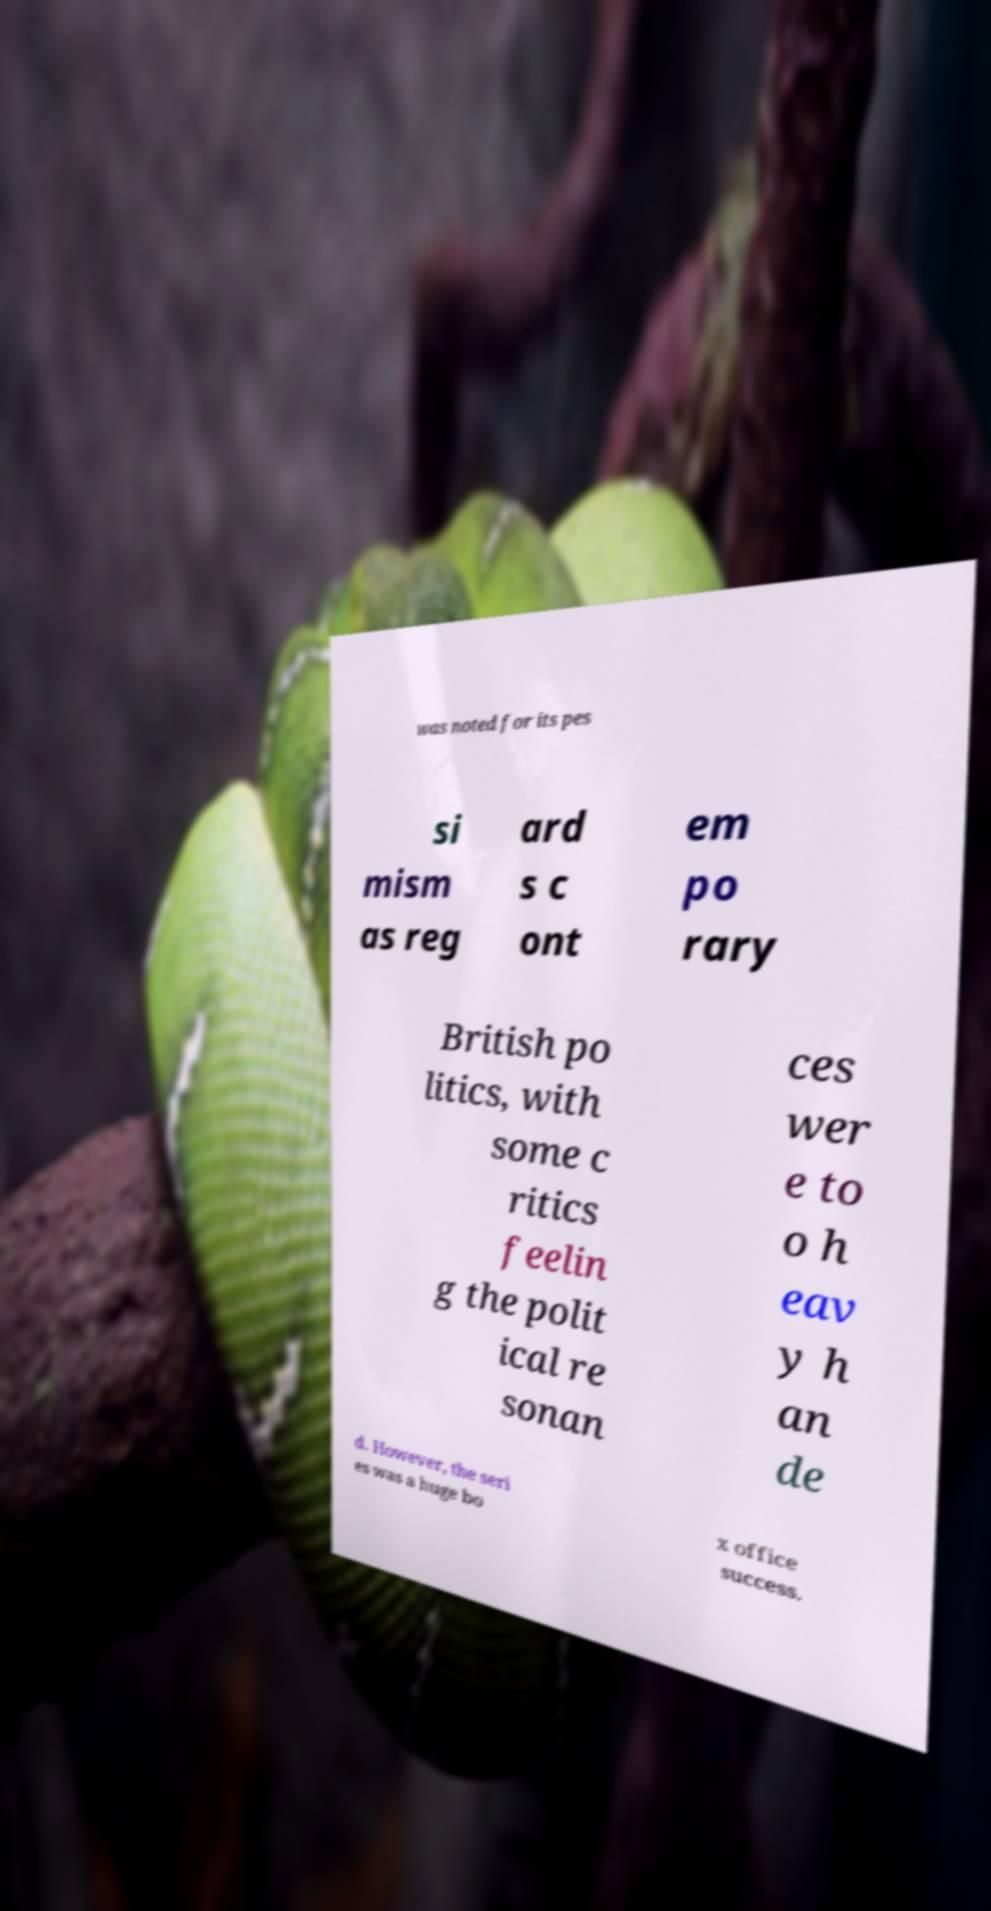What messages or text are displayed in this image? I need them in a readable, typed format. was noted for its pes si mism as reg ard s c ont em po rary British po litics, with some c ritics feelin g the polit ical re sonan ces wer e to o h eav y h an de d. However, the seri es was a huge bo x office success. 